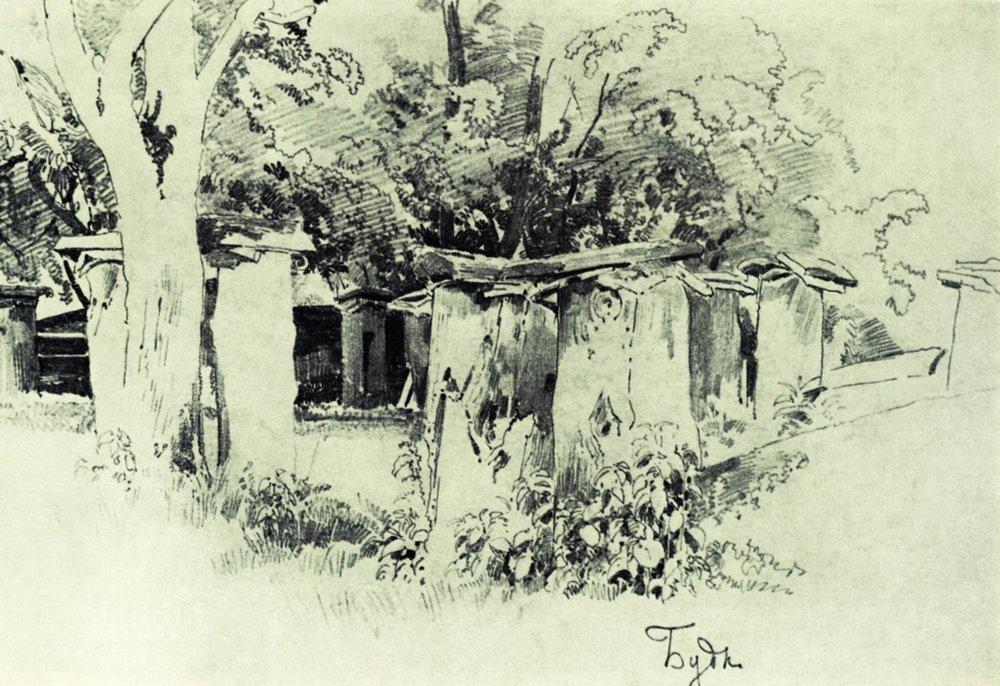How does the artist use light and shadow in this sketch? The artist skillfully utilizes light and shadow to create depth and texture. The contrasts between the dark, detailed trees and the lighter sky suggest sunlight filtering through the branches, which enhances the three-dimensionality of the scene. Shadows under the roofs of the houses and in the foliage add to the realism, making the rural landscape appear more vivid and tangible. 